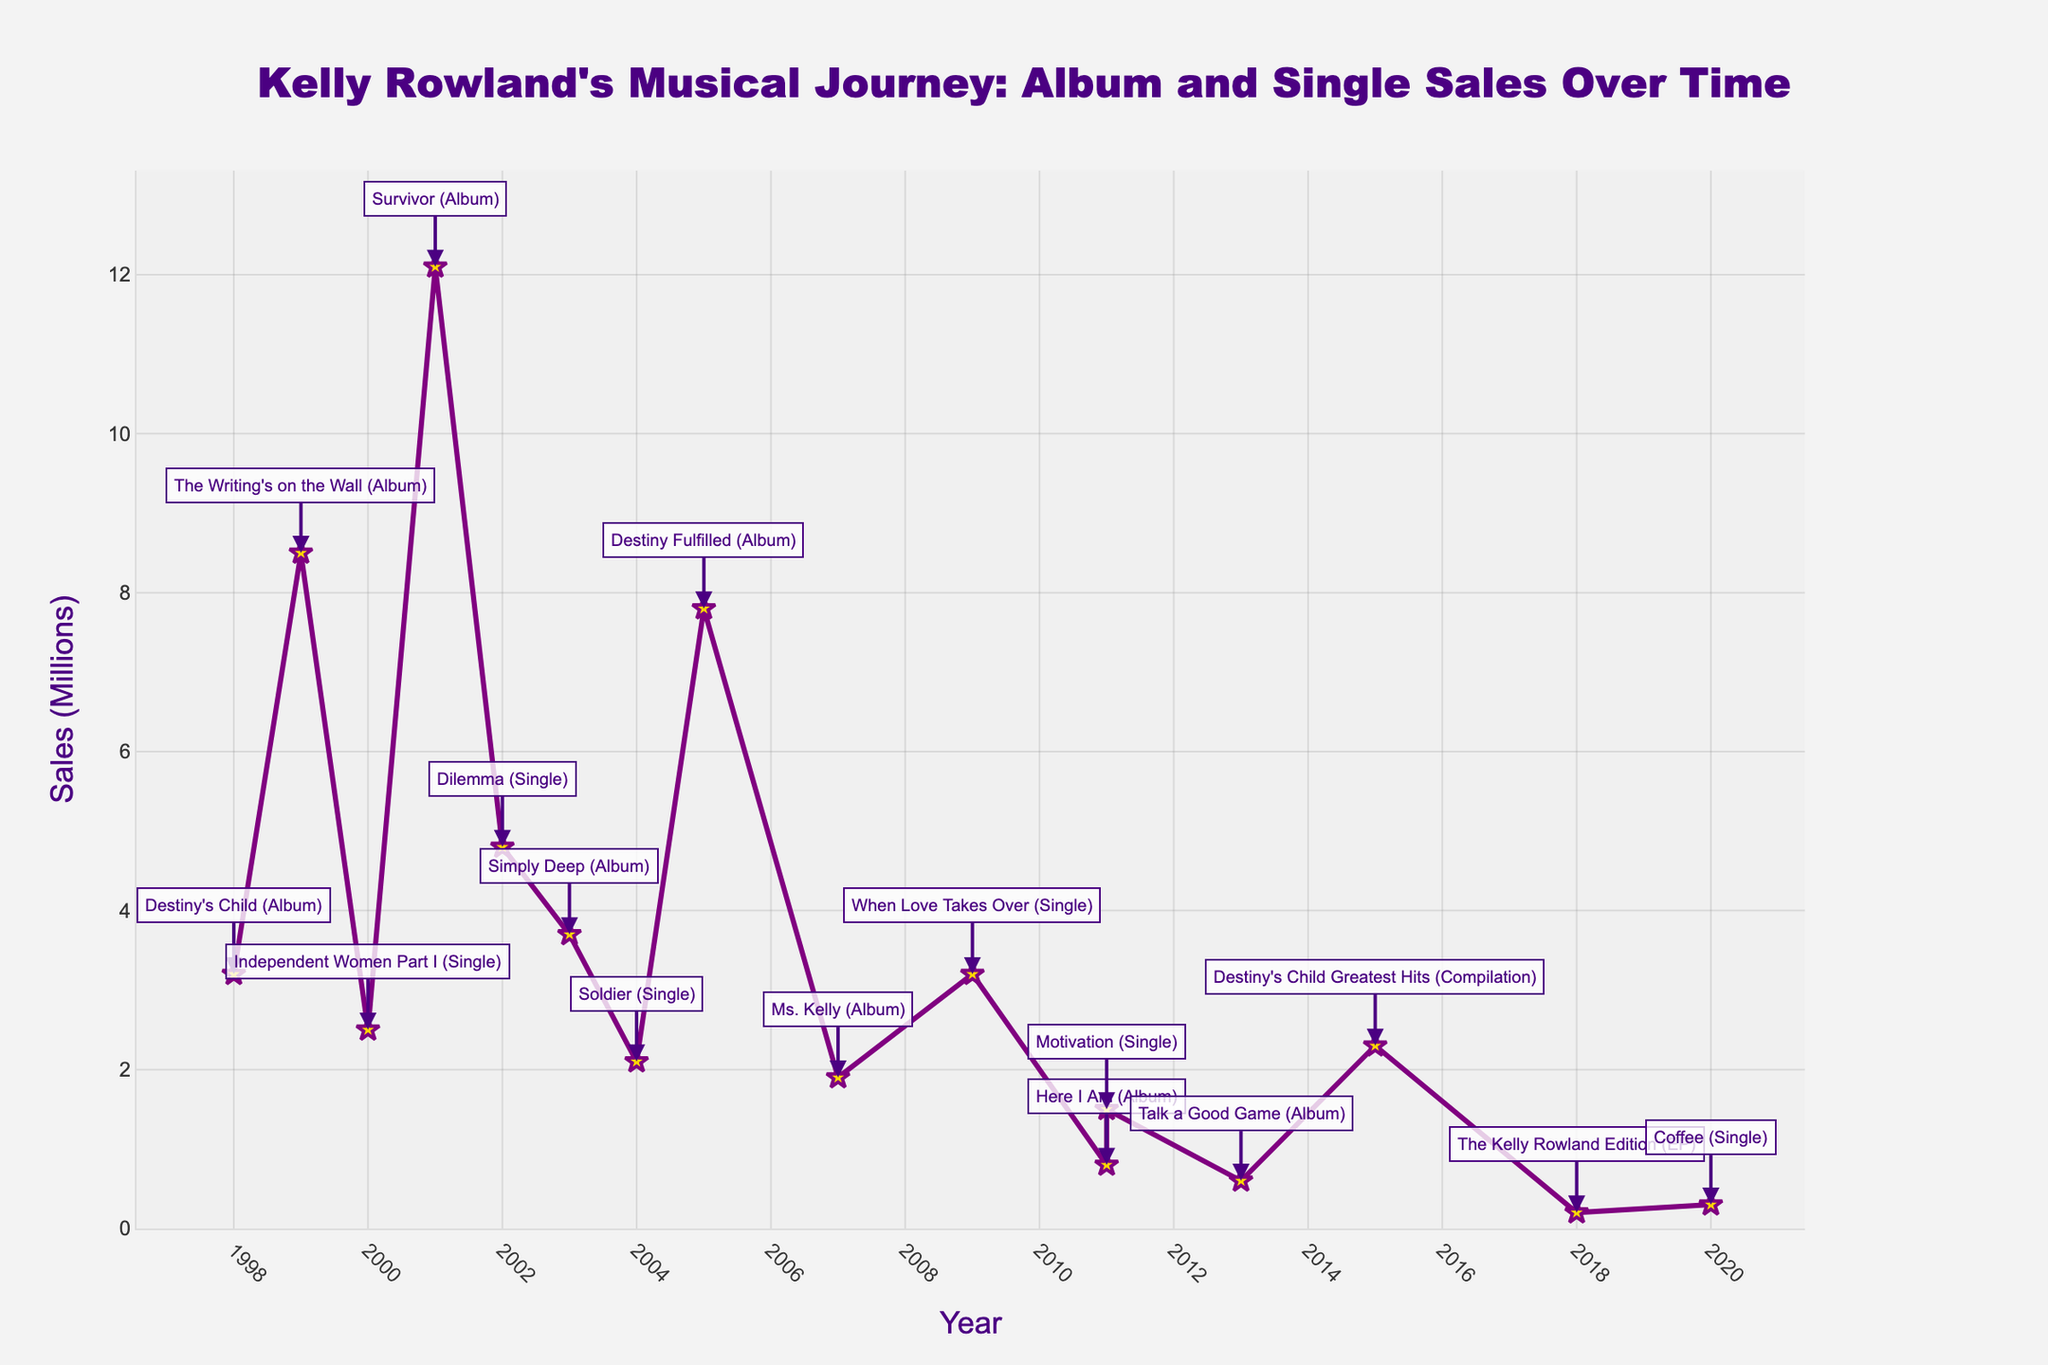What is the highest album or single sale by Kelly Rowland? By examining the visual data, we see that the highest peak in sales on the line chart occurs in 2001 with the album "Survivor". This is indicated both by the height of the data point and the annotation provided.
Answer: 12.1 million What was the total sales for Destiny’s Child's albums in the years 1998, 1999, 2001, and 2005? Summing up the sales for the respective years: 1998 (3.2 million), 1999 (8.5 million), 2001 (12.1 million), and 2005 (7.8 million). The total is 3.2 + 8.5 + 12.1 + 7.8.
Answer: 31.6 million Which single released by Kelly Rowland had the highest sales? Looking at the annotations for the singles, the single with the highest peak is "Dilemma" released in 2002.
Answer: 4.8 million How did the sales in 2001 compare to those in 2013? To compare, we go to the data points and annotations for the years 2001 and 2013. The album "Survivor" in 2001 had sales of 12.1 million, while the album "Talk a Good Game" in 2013 had sales of 0.6 million. 2001 sales are much higher than 2013.
Answer: 2001 sales are higher What is the difference in sales between "The Writing's on the Wall" and "Ms. Kelly"? From the figure, "The Writing's on the Wall" (1999) had sales of 8.5 million and "Ms. Kelly" (2007) had sales of 1.9 million. The difference is 8.5 - 1.9.
Answer: 6.6 million Are there any years in which no albums or singles were released? The figure provides annotated data points for specific years. Observing these, we see that no annotations exist for certain years such as 2006, 2008, and 2012.
Answer: Yes Which has higher sales: "Simply Deep" or "Motivation"? Looking at their corresponding data points, "Simply Deep" (2003) had 3.7 million sales, whereas "Motivation" (2011) had 1.5 million sales. "Simply Deep" had higher sales.
Answer: Simply Deep What is the average sales of singles released from 2000 to 2020? Identifying the singles and their sales: "Independent Women Part I" (2.5M, 2000), "Dilemma" (4.8M, 2002), "Soldier" (2.1M, 2004), "When Love Takes Over" (3.2M, 2009), "Motivation" (1.5M, 2011), and "Coffee" (0.3M, 2020). Average = (2.5 + 4.8 + 2.1 + 3.2 + 1.5 + 0.3) / 6.
Answer: 2.4 million Which year had the lowest sales for a Kelly Rowland album and what was the album? Consulting the sales data visually, the lowest data point labeled as an album is "The Kelly Rowland Edition" in 2018 with sales of 0.2 million.
Answer: 2018, The Kelly Rowland Edition What is the combined sales of Kelly's solo and group albums released from 2003 to 2013? Summing these up: "Simply Deep" (2003, 3.7M), "Destiny Fulfilled" (2005, 7.8M), "Ms. Kelly" (2007, 1.9M), "Here I Am" (2011, 0.8M), "Talk a Good Game" (2013, 0.6M). Total = 3.7 + 7.8 + 1.9 + 0.8 + 0.6.
Answer: 14.8 million 